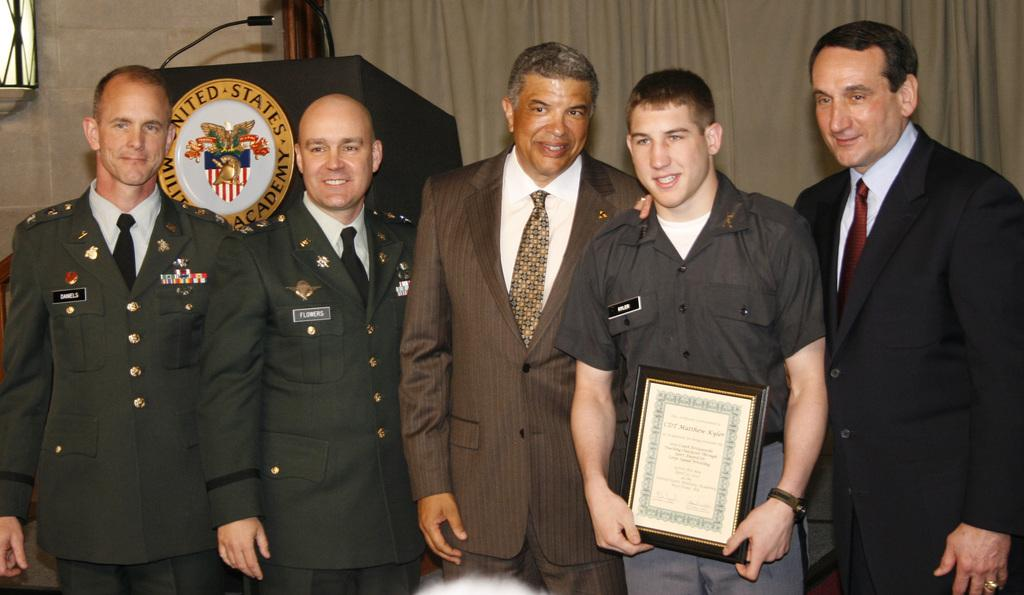What are the people in the image doing? The people in the image are standing. What is the person holding in their hands? One person is holding a certificate in their hands. What can be seen in the background of the image? There is a curtain and a podium in the background of the image. What is attached to the podium? A microphone is attached to the podium. What type of tree can be seen behind the people in the image? There is no tree visible in the image; it only shows people standing, a certificate, a curtain, a podium, and a microphone. 